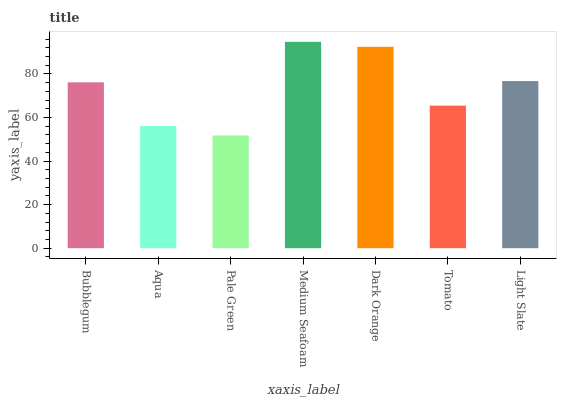Is Pale Green the minimum?
Answer yes or no. Yes. Is Medium Seafoam the maximum?
Answer yes or no. Yes. Is Aqua the minimum?
Answer yes or no. No. Is Aqua the maximum?
Answer yes or no. No. Is Bubblegum greater than Aqua?
Answer yes or no. Yes. Is Aqua less than Bubblegum?
Answer yes or no. Yes. Is Aqua greater than Bubblegum?
Answer yes or no. No. Is Bubblegum less than Aqua?
Answer yes or no. No. Is Bubblegum the high median?
Answer yes or no. Yes. Is Bubblegum the low median?
Answer yes or no. Yes. Is Medium Seafoam the high median?
Answer yes or no. No. Is Medium Seafoam the low median?
Answer yes or no. No. 